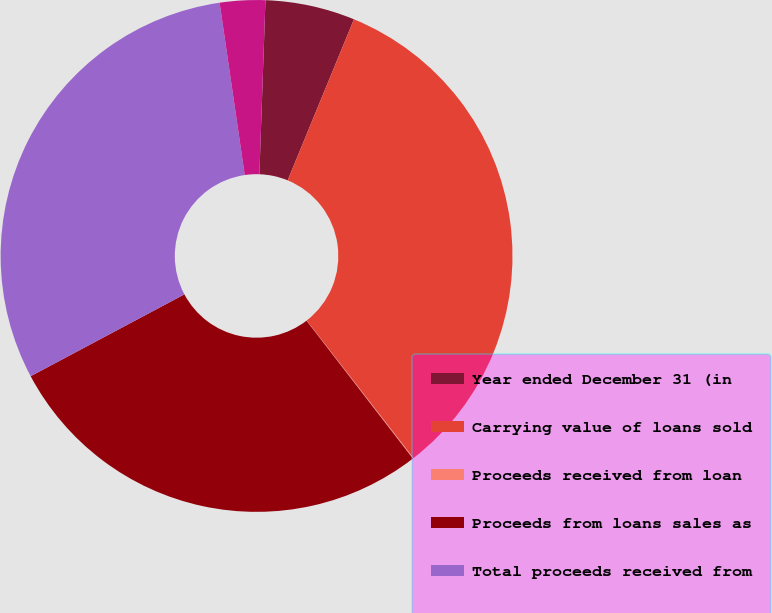Convert chart. <chart><loc_0><loc_0><loc_500><loc_500><pie_chart><fcel>Year ended December 31 (in<fcel>Carrying value of loans sold<fcel>Proceeds received from loan<fcel>Proceeds from loans sales as<fcel>Total proceeds received from<fcel>Gains/(losses) on loan sales<nl><fcel>5.66%<fcel>33.28%<fcel>0.05%<fcel>27.67%<fcel>30.48%<fcel>2.86%<nl></chart> 